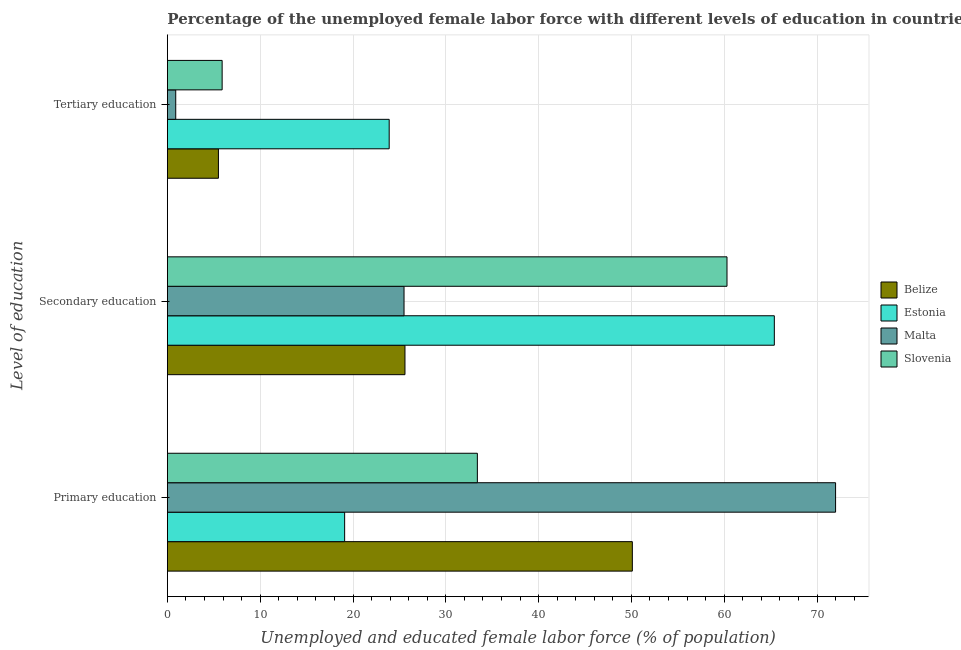How many different coloured bars are there?
Provide a short and direct response. 4. How many groups of bars are there?
Offer a very short reply. 3. Are the number of bars per tick equal to the number of legend labels?
Make the answer very short. Yes. Are the number of bars on each tick of the Y-axis equal?
Provide a short and direct response. Yes. How many bars are there on the 1st tick from the top?
Your answer should be compact. 4. What is the label of the 2nd group of bars from the top?
Your answer should be very brief. Secondary education. What is the percentage of female labor force who received secondary education in Slovenia?
Keep it short and to the point. 60.3. Across all countries, what is the minimum percentage of female labor force who received primary education?
Your response must be concise. 19.1. In which country was the percentage of female labor force who received tertiary education maximum?
Keep it short and to the point. Estonia. In which country was the percentage of female labor force who received secondary education minimum?
Offer a terse response. Malta. What is the total percentage of female labor force who received secondary education in the graph?
Ensure brevity in your answer.  176.8. What is the difference between the percentage of female labor force who received tertiary education in Belize and that in Malta?
Provide a short and direct response. 4.6. What is the difference between the percentage of female labor force who received secondary education in Belize and the percentage of female labor force who received primary education in Slovenia?
Make the answer very short. -7.8. What is the average percentage of female labor force who received tertiary education per country?
Your answer should be very brief. 9.05. What is the difference between the percentage of female labor force who received tertiary education and percentage of female labor force who received primary education in Estonia?
Make the answer very short. 4.8. What is the ratio of the percentage of female labor force who received secondary education in Slovenia to that in Malta?
Your answer should be very brief. 2.36. Is the percentage of female labor force who received secondary education in Malta less than that in Estonia?
Your response must be concise. Yes. Is the difference between the percentage of female labor force who received primary education in Slovenia and Malta greater than the difference between the percentage of female labor force who received tertiary education in Slovenia and Malta?
Provide a short and direct response. No. What is the difference between the highest and the second highest percentage of female labor force who received secondary education?
Offer a very short reply. 5.1. What is the difference between the highest and the lowest percentage of female labor force who received tertiary education?
Your answer should be very brief. 23. In how many countries, is the percentage of female labor force who received primary education greater than the average percentage of female labor force who received primary education taken over all countries?
Ensure brevity in your answer.  2. What does the 3rd bar from the top in Secondary education represents?
Your answer should be compact. Estonia. What does the 4th bar from the bottom in Secondary education represents?
Provide a short and direct response. Slovenia. How many bars are there?
Keep it short and to the point. 12. Are all the bars in the graph horizontal?
Your response must be concise. Yes. What is the difference between two consecutive major ticks on the X-axis?
Keep it short and to the point. 10. Does the graph contain grids?
Provide a succinct answer. Yes. What is the title of the graph?
Provide a short and direct response. Percentage of the unemployed female labor force with different levels of education in countries. Does "Kuwait" appear as one of the legend labels in the graph?
Make the answer very short. No. What is the label or title of the X-axis?
Offer a very short reply. Unemployed and educated female labor force (% of population). What is the label or title of the Y-axis?
Your answer should be compact. Level of education. What is the Unemployed and educated female labor force (% of population) in Belize in Primary education?
Provide a short and direct response. 50.1. What is the Unemployed and educated female labor force (% of population) of Estonia in Primary education?
Provide a short and direct response. 19.1. What is the Unemployed and educated female labor force (% of population) in Slovenia in Primary education?
Provide a short and direct response. 33.4. What is the Unemployed and educated female labor force (% of population) in Belize in Secondary education?
Ensure brevity in your answer.  25.6. What is the Unemployed and educated female labor force (% of population) in Estonia in Secondary education?
Offer a very short reply. 65.4. What is the Unemployed and educated female labor force (% of population) in Malta in Secondary education?
Make the answer very short. 25.5. What is the Unemployed and educated female labor force (% of population) of Slovenia in Secondary education?
Your response must be concise. 60.3. What is the Unemployed and educated female labor force (% of population) of Belize in Tertiary education?
Keep it short and to the point. 5.5. What is the Unemployed and educated female labor force (% of population) of Estonia in Tertiary education?
Your response must be concise. 23.9. What is the Unemployed and educated female labor force (% of population) in Malta in Tertiary education?
Your answer should be compact. 0.9. What is the Unemployed and educated female labor force (% of population) of Slovenia in Tertiary education?
Your answer should be very brief. 5.9. Across all Level of education, what is the maximum Unemployed and educated female labor force (% of population) in Belize?
Give a very brief answer. 50.1. Across all Level of education, what is the maximum Unemployed and educated female labor force (% of population) of Estonia?
Provide a short and direct response. 65.4. Across all Level of education, what is the maximum Unemployed and educated female labor force (% of population) in Malta?
Ensure brevity in your answer.  72. Across all Level of education, what is the maximum Unemployed and educated female labor force (% of population) in Slovenia?
Your answer should be very brief. 60.3. Across all Level of education, what is the minimum Unemployed and educated female labor force (% of population) of Belize?
Your answer should be compact. 5.5. Across all Level of education, what is the minimum Unemployed and educated female labor force (% of population) of Estonia?
Offer a very short reply. 19.1. Across all Level of education, what is the minimum Unemployed and educated female labor force (% of population) in Malta?
Ensure brevity in your answer.  0.9. Across all Level of education, what is the minimum Unemployed and educated female labor force (% of population) in Slovenia?
Keep it short and to the point. 5.9. What is the total Unemployed and educated female labor force (% of population) of Belize in the graph?
Offer a terse response. 81.2. What is the total Unemployed and educated female labor force (% of population) of Estonia in the graph?
Provide a succinct answer. 108.4. What is the total Unemployed and educated female labor force (% of population) of Malta in the graph?
Give a very brief answer. 98.4. What is the total Unemployed and educated female labor force (% of population) in Slovenia in the graph?
Make the answer very short. 99.6. What is the difference between the Unemployed and educated female labor force (% of population) in Estonia in Primary education and that in Secondary education?
Provide a succinct answer. -46.3. What is the difference between the Unemployed and educated female labor force (% of population) of Malta in Primary education and that in Secondary education?
Provide a succinct answer. 46.5. What is the difference between the Unemployed and educated female labor force (% of population) of Slovenia in Primary education and that in Secondary education?
Provide a succinct answer. -26.9. What is the difference between the Unemployed and educated female labor force (% of population) in Belize in Primary education and that in Tertiary education?
Give a very brief answer. 44.6. What is the difference between the Unemployed and educated female labor force (% of population) in Malta in Primary education and that in Tertiary education?
Offer a terse response. 71.1. What is the difference between the Unemployed and educated female labor force (% of population) in Slovenia in Primary education and that in Tertiary education?
Ensure brevity in your answer.  27.5. What is the difference between the Unemployed and educated female labor force (% of population) of Belize in Secondary education and that in Tertiary education?
Your answer should be compact. 20.1. What is the difference between the Unemployed and educated female labor force (% of population) in Estonia in Secondary education and that in Tertiary education?
Offer a terse response. 41.5. What is the difference between the Unemployed and educated female labor force (% of population) of Malta in Secondary education and that in Tertiary education?
Provide a succinct answer. 24.6. What is the difference between the Unemployed and educated female labor force (% of population) of Slovenia in Secondary education and that in Tertiary education?
Keep it short and to the point. 54.4. What is the difference between the Unemployed and educated female labor force (% of population) of Belize in Primary education and the Unemployed and educated female labor force (% of population) of Estonia in Secondary education?
Your response must be concise. -15.3. What is the difference between the Unemployed and educated female labor force (% of population) of Belize in Primary education and the Unemployed and educated female labor force (% of population) of Malta in Secondary education?
Give a very brief answer. 24.6. What is the difference between the Unemployed and educated female labor force (% of population) in Belize in Primary education and the Unemployed and educated female labor force (% of population) in Slovenia in Secondary education?
Make the answer very short. -10.2. What is the difference between the Unemployed and educated female labor force (% of population) of Estonia in Primary education and the Unemployed and educated female labor force (% of population) of Slovenia in Secondary education?
Make the answer very short. -41.2. What is the difference between the Unemployed and educated female labor force (% of population) in Malta in Primary education and the Unemployed and educated female labor force (% of population) in Slovenia in Secondary education?
Your answer should be compact. 11.7. What is the difference between the Unemployed and educated female labor force (% of population) in Belize in Primary education and the Unemployed and educated female labor force (% of population) in Estonia in Tertiary education?
Your response must be concise. 26.2. What is the difference between the Unemployed and educated female labor force (% of population) in Belize in Primary education and the Unemployed and educated female labor force (% of population) in Malta in Tertiary education?
Your response must be concise. 49.2. What is the difference between the Unemployed and educated female labor force (% of population) of Belize in Primary education and the Unemployed and educated female labor force (% of population) of Slovenia in Tertiary education?
Your answer should be compact. 44.2. What is the difference between the Unemployed and educated female labor force (% of population) of Estonia in Primary education and the Unemployed and educated female labor force (% of population) of Malta in Tertiary education?
Your response must be concise. 18.2. What is the difference between the Unemployed and educated female labor force (% of population) in Malta in Primary education and the Unemployed and educated female labor force (% of population) in Slovenia in Tertiary education?
Offer a very short reply. 66.1. What is the difference between the Unemployed and educated female labor force (% of population) of Belize in Secondary education and the Unemployed and educated female labor force (% of population) of Malta in Tertiary education?
Offer a terse response. 24.7. What is the difference between the Unemployed and educated female labor force (% of population) in Estonia in Secondary education and the Unemployed and educated female labor force (% of population) in Malta in Tertiary education?
Offer a very short reply. 64.5. What is the difference between the Unemployed and educated female labor force (% of population) of Estonia in Secondary education and the Unemployed and educated female labor force (% of population) of Slovenia in Tertiary education?
Your response must be concise. 59.5. What is the difference between the Unemployed and educated female labor force (% of population) of Malta in Secondary education and the Unemployed and educated female labor force (% of population) of Slovenia in Tertiary education?
Offer a very short reply. 19.6. What is the average Unemployed and educated female labor force (% of population) of Belize per Level of education?
Your answer should be compact. 27.07. What is the average Unemployed and educated female labor force (% of population) in Estonia per Level of education?
Your response must be concise. 36.13. What is the average Unemployed and educated female labor force (% of population) of Malta per Level of education?
Make the answer very short. 32.8. What is the average Unemployed and educated female labor force (% of population) in Slovenia per Level of education?
Offer a very short reply. 33.2. What is the difference between the Unemployed and educated female labor force (% of population) of Belize and Unemployed and educated female labor force (% of population) of Malta in Primary education?
Offer a terse response. -21.9. What is the difference between the Unemployed and educated female labor force (% of population) of Belize and Unemployed and educated female labor force (% of population) of Slovenia in Primary education?
Keep it short and to the point. 16.7. What is the difference between the Unemployed and educated female labor force (% of population) of Estonia and Unemployed and educated female labor force (% of population) of Malta in Primary education?
Ensure brevity in your answer.  -52.9. What is the difference between the Unemployed and educated female labor force (% of population) of Estonia and Unemployed and educated female labor force (% of population) of Slovenia in Primary education?
Offer a terse response. -14.3. What is the difference between the Unemployed and educated female labor force (% of population) in Malta and Unemployed and educated female labor force (% of population) in Slovenia in Primary education?
Offer a very short reply. 38.6. What is the difference between the Unemployed and educated female labor force (% of population) in Belize and Unemployed and educated female labor force (% of population) in Estonia in Secondary education?
Your answer should be very brief. -39.8. What is the difference between the Unemployed and educated female labor force (% of population) of Belize and Unemployed and educated female labor force (% of population) of Malta in Secondary education?
Provide a succinct answer. 0.1. What is the difference between the Unemployed and educated female labor force (% of population) of Belize and Unemployed and educated female labor force (% of population) of Slovenia in Secondary education?
Your answer should be very brief. -34.7. What is the difference between the Unemployed and educated female labor force (% of population) in Estonia and Unemployed and educated female labor force (% of population) in Malta in Secondary education?
Your response must be concise. 39.9. What is the difference between the Unemployed and educated female labor force (% of population) of Estonia and Unemployed and educated female labor force (% of population) of Slovenia in Secondary education?
Offer a terse response. 5.1. What is the difference between the Unemployed and educated female labor force (% of population) in Malta and Unemployed and educated female labor force (% of population) in Slovenia in Secondary education?
Provide a short and direct response. -34.8. What is the difference between the Unemployed and educated female labor force (% of population) of Belize and Unemployed and educated female labor force (% of population) of Estonia in Tertiary education?
Your answer should be very brief. -18.4. What is the difference between the Unemployed and educated female labor force (% of population) in Estonia and Unemployed and educated female labor force (% of population) in Malta in Tertiary education?
Your answer should be very brief. 23. What is the difference between the Unemployed and educated female labor force (% of population) of Estonia and Unemployed and educated female labor force (% of population) of Slovenia in Tertiary education?
Give a very brief answer. 18. What is the ratio of the Unemployed and educated female labor force (% of population) of Belize in Primary education to that in Secondary education?
Ensure brevity in your answer.  1.96. What is the ratio of the Unemployed and educated female labor force (% of population) of Estonia in Primary education to that in Secondary education?
Offer a terse response. 0.29. What is the ratio of the Unemployed and educated female labor force (% of population) of Malta in Primary education to that in Secondary education?
Provide a short and direct response. 2.82. What is the ratio of the Unemployed and educated female labor force (% of population) of Slovenia in Primary education to that in Secondary education?
Offer a terse response. 0.55. What is the ratio of the Unemployed and educated female labor force (% of population) of Belize in Primary education to that in Tertiary education?
Offer a very short reply. 9.11. What is the ratio of the Unemployed and educated female labor force (% of population) of Estonia in Primary education to that in Tertiary education?
Ensure brevity in your answer.  0.8. What is the ratio of the Unemployed and educated female labor force (% of population) in Slovenia in Primary education to that in Tertiary education?
Your answer should be very brief. 5.66. What is the ratio of the Unemployed and educated female labor force (% of population) of Belize in Secondary education to that in Tertiary education?
Make the answer very short. 4.65. What is the ratio of the Unemployed and educated female labor force (% of population) of Estonia in Secondary education to that in Tertiary education?
Provide a succinct answer. 2.74. What is the ratio of the Unemployed and educated female labor force (% of population) in Malta in Secondary education to that in Tertiary education?
Keep it short and to the point. 28.33. What is the ratio of the Unemployed and educated female labor force (% of population) in Slovenia in Secondary education to that in Tertiary education?
Offer a terse response. 10.22. What is the difference between the highest and the second highest Unemployed and educated female labor force (% of population) in Estonia?
Your answer should be very brief. 41.5. What is the difference between the highest and the second highest Unemployed and educated female labor force (% of population) of Malta?
Give a very brief answer. 46.5. What is the difference between the highest and the second highest Unemployed and educated female labor force (% of population) in Slovenia?
Your response must be concise. 26.9. What is the difference between the highest and the lowest Unemployed and educated female labor force (% of population) of Belize?
Keep it short and to the point. 44.6. What is the difference between the highest and the lowest Unemployed and educated female labor force (% of population) of Estonia?
Offer a very short reply. 46.3. What is the difference between the highest and the lowest Unemployed and educated female labor force (% of population) of Malta?
Keep it short and to the point. 71.1. What is the difference between the highest and the lowest Unemployed and educated female labor force (% of population) in Slovenia?
Your response must be concise. 54.4. 